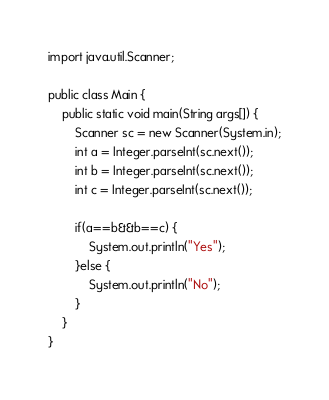Convert code to text. <code><loc_0><loc_0><loc_500><loc_500><_Java_>import java.util.Scanner;

public class Main {
	public static void main(String args[]) {	
		Scanner sc = new Scanner(System.in);
		int a = Integer.parseInt(sc.next());
		int b = Integer.parseInt(sc.next());
		int c = Integer.parseInt(sc.next());
		
		if(a==b&&b==c) {
			System.out.println("Yes");
		}else {
			System.out.println("No");
		}
	}
}
</code> 